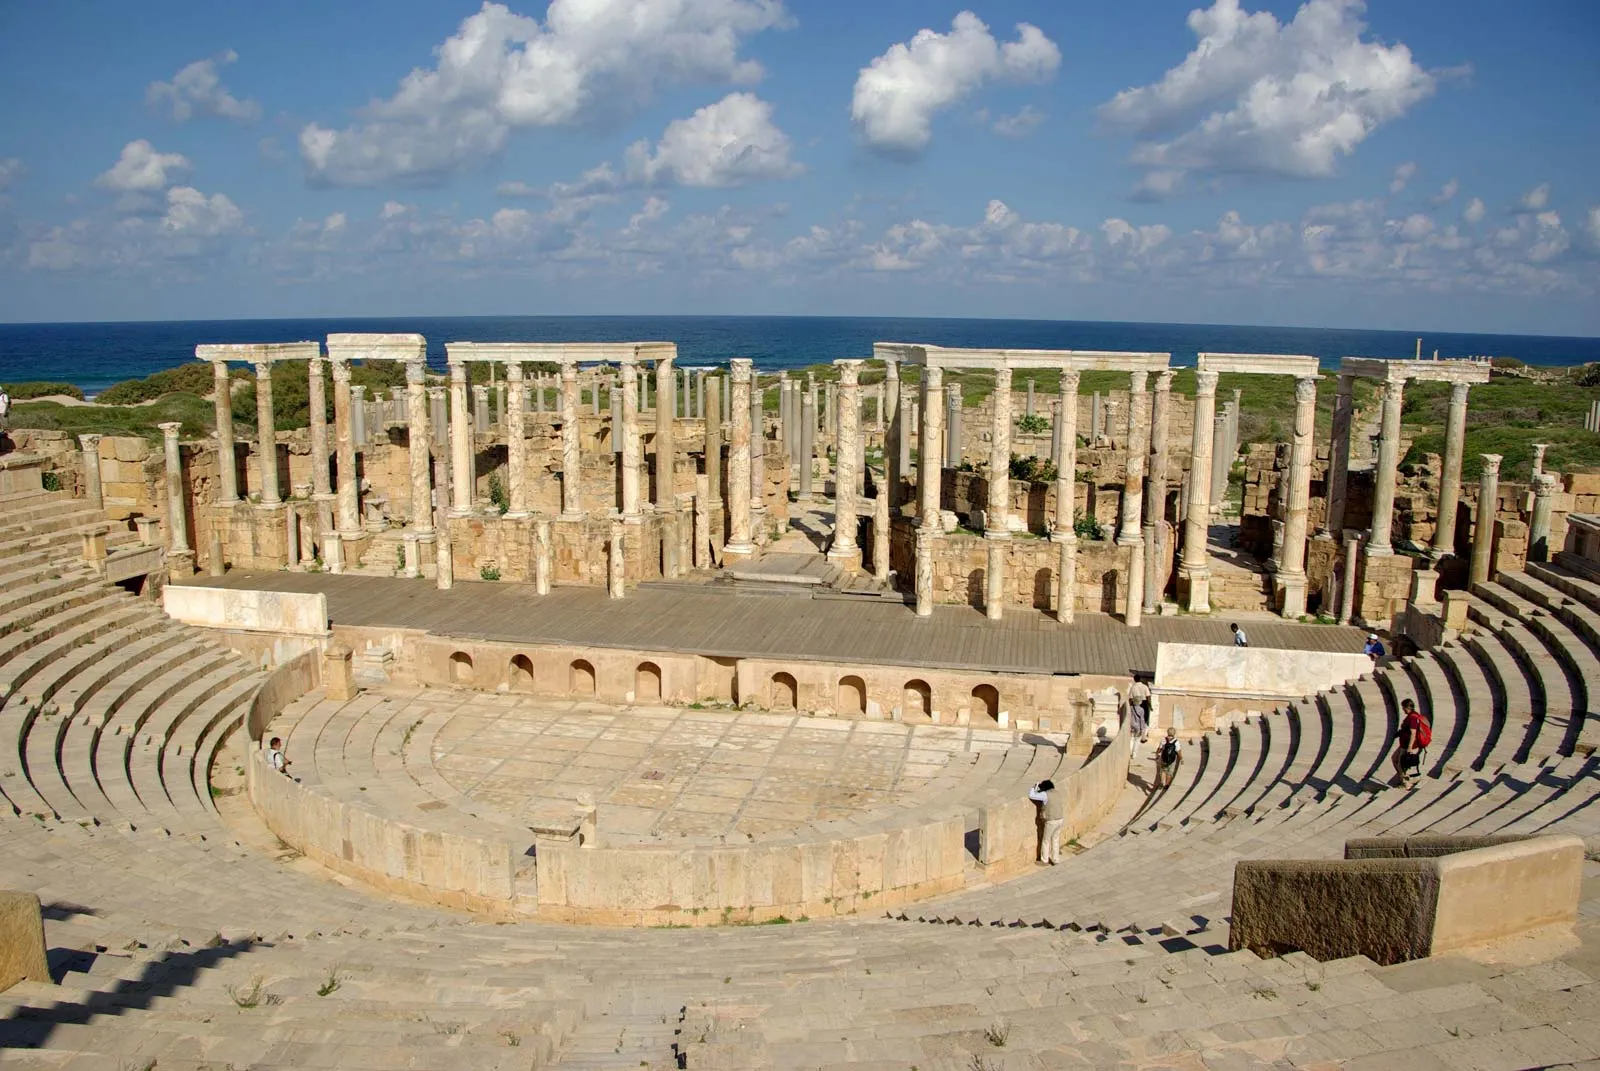Can you re-imagine this site as a futuristic space filled with advanced technology? In a futuristic re-imagining, the amphitheater of Leptis Magna becomes a seamlessly integrated hub of advanced technology and preservation. The seats are refurbished with self-repairing materials, embedding augmented reality displays that instantaneously project historical reenactments or educational content for visitors. Holographic guides float gracefully through the space, providing interactive and immersive storytelling about the site's history. Drones hover purposefully, ensuring maintenance and security, while energy harvesting from the environment powers informative panels and virtual displays. The ruins are cocooned in an invisible shield that monitors environmental conditions to prevent deterioration. Visitors can don virtual reality suits to experience the amphitheater as it was in its prime, transcending time to engage with the past and future in one harmonious space. This fusion of ancient architecture and cutting-edge technology creates a living monument that not only honors but perpetuates the legacy of Leptis Magna. 